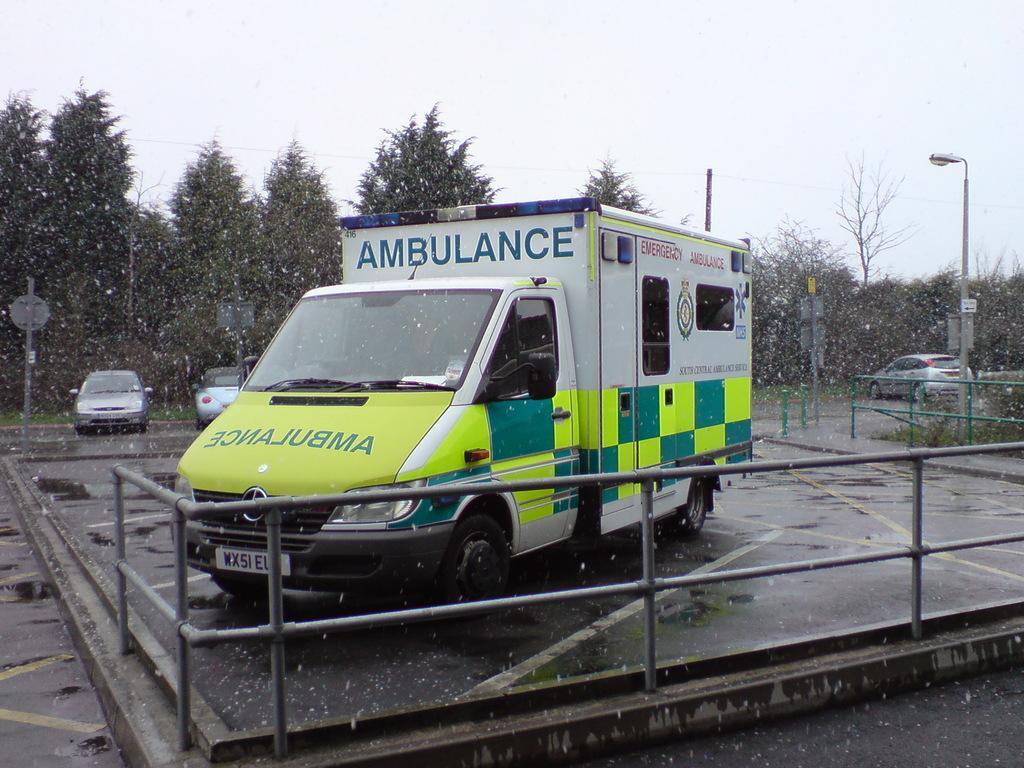Please provide a concise description of this image. In the image there is an ambulance on the ground and there is a fencing around the ambulance, behind that there are some other vehicles beside the road and in the background there are many trees. 